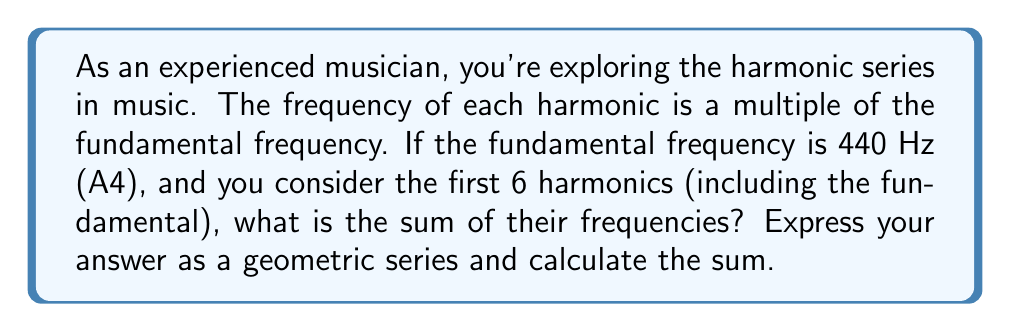Can you answer this question? Let's approach this step-by-step:

1) The harmonic series in music forms a geometric sequence where each term is a multiple of the fundamental frequency.

2) With a fundamental frequency of 440 Hz, the first 6 harmonics are:
   1st harmonic (fundamental): 440 Hz
   2nd harmonic: 880 Hz
   3rd harmonic: 1320 Hz
   4th harmonic: 1760 Hz
   5th harmonic: 2200 Hz
   6th harmonic: 2640 Hz

3) We can express this as a geometric series:
   $$ 440 + 880 + 1320 + 1760 + 2200 + 2640 $$

4) Factoring out 440, we get:
   $$ 440(1 + 2 + 3 + 4 + 5 + 6) $$

5) This is a geometric series with:
   First term $a = 440$
   Common ratio $r = 1$
   Number of terms $n = 6$

6) The sum of a geometric series is given by the formula:
   $$ S_n = \frac{a(1-r^n)}{1-r} $$
   When $r = 1$, this simplifies to:
   $$ S_n = an $$

7) Substituting our values:
   $$ S_6 = 440 \cdot 6 = 2640 $$

8) Therefore, the sum of the frequencies of the first 6 harmonics is 2640 Hz.
Answer: 2640 Hz 